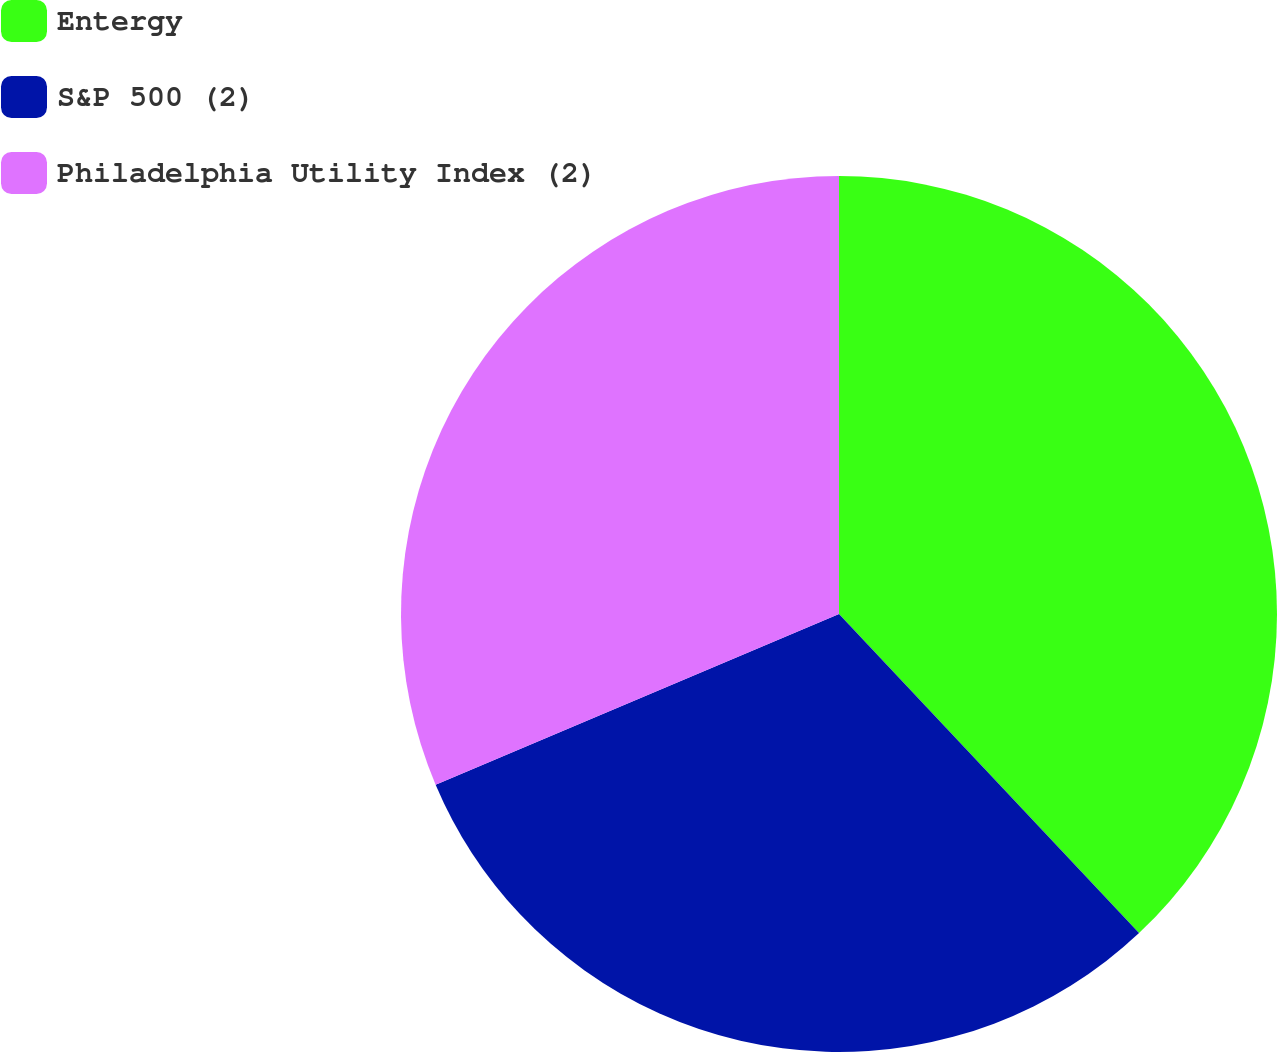<chart> <loc_0><loc_0><loc_500><loc_500><pie_chart><fcel>Entergy<fcel>S&P 500 (2)<fcel>Philadelphia Utility Index (2)<nl><fcel>37.99%<fcel>30.64%<fcel>31.37%<nl></chart> 